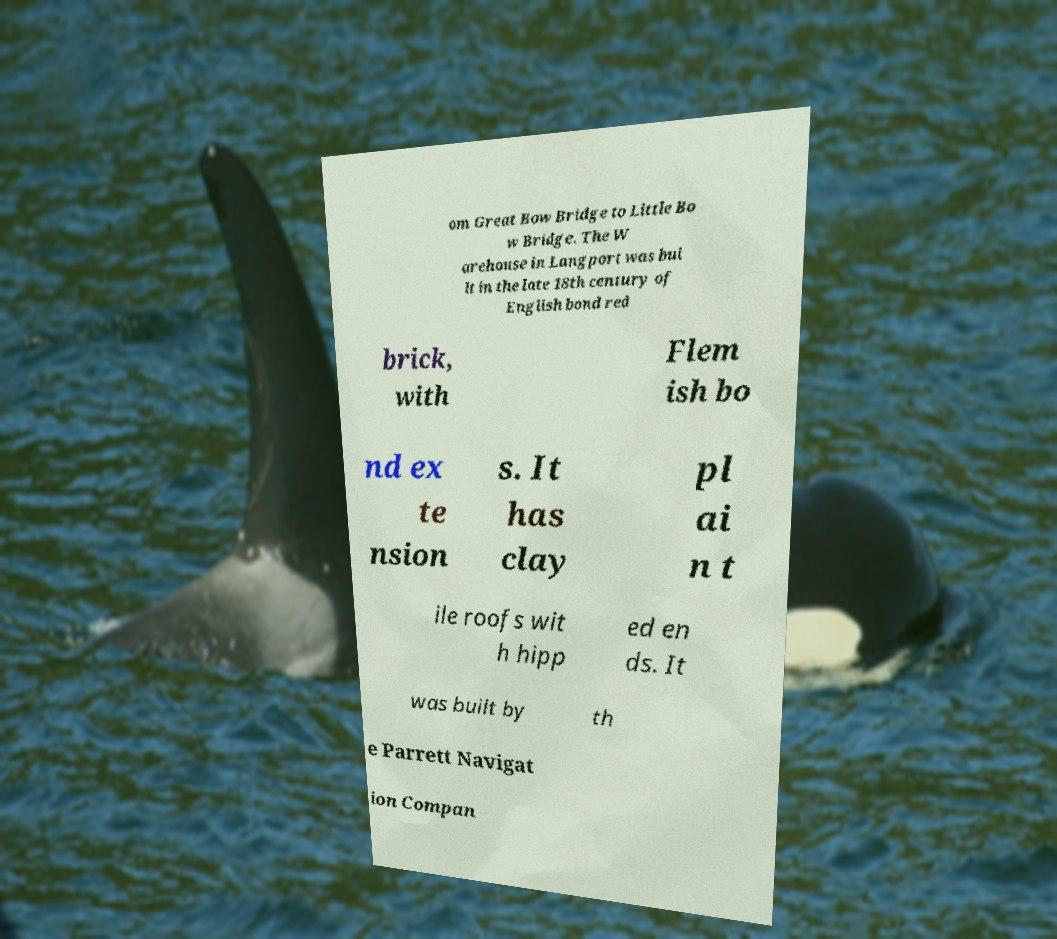What messages or text are displayed in this image? I need them in a readable, typed format. om Great Bow Bridge to Little Bo w Bridge. The W arehouse in Langport was bui lt in the late 18th century of English bond red brick, with Flem ish bo nd ex te nsion s. It has clay pl ai n t ile roofs wit h hipp ed en ds. It was built by th e Parrett Navigat ion Compan 